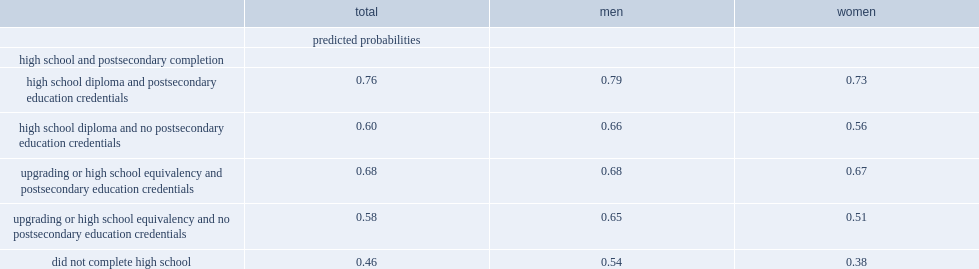Give me the full table as a dictionary. {'header': ['', 'total', 'men', 'women'], 'rows': [['', 'predicted probabilities', '', ''], ['high school and postsecondary completion', '', '', ''], ['high school diploma and postsecondary education credentials', '0.76', '0.79', '0.73'], ['high school diploma and no postsecondary education credentials', '0.60', '0.66', '0.56'], ['upgrading or high school equivalency and postsecondary education credentials', '0.68', '0.68', '0.67'], ['upgrading or high school equivalency and no postsecondary education credentials', '0.58', '0.65', '0.51'], ['did not complete high school', '0.46', '0.54', '0.38']]} What was the probability of being employed for men and women who completed an upgrading or high school equivalency program and postsecondary education? 0.68. What was the probability among those who did not complete high school? 0.46. For those who completed an upgrading or high school equivalency program but did not obtain postsecondary qualifications, what was the probability of employment? 0.58. What was the probability of employment which was highest among indigenous adults who earned a standard high school diploma and postsecondary credentials? 0.76. What was the probability of employment was lower among those who had a standard high school diploma but did not have any postsecondary credentials? 0.6. What was the probability of employment for those who completed an upgrading or equivalency program but no postsecondary education? 0.58. What was the probability of being employed among indigenous women who completed an upgrading program and postsecondary qualifications? 0.67. How many percent among those who did not complete high school? 0.38. Among those who completed a high school equivalency or upgrading program but did not obtain postsecondary qualifications, what was the probability of employment? 0.51. What was the probability of employment for indigenous men who completed an upgrading or equivalency program and postsecondary qualification? 0.68. How many percent among those who left school without a diploma? 0.54. Among indigenous men with no postsecondary qualifications, what was the probability of employment based on the completion of a high school diploma? 0.66. Among indigenous men with no postsecondary qualifications, what was the probability of employment based on the completion of high school equivalency or upgrading? 0.65. 